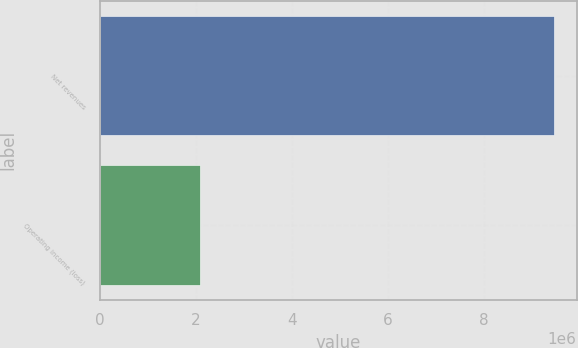<chart> <loc_0><loc_0><loc_500><loc_500><bar_chart><fcel>Net revenues<fcel>Operating income (loss)<nl><fcel>9.45512e+06<fcel>2.07979e+06<nl></chart> 